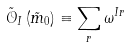<formula> <loc_0><loc_0><loc_500><loc_500>\tilde { \mathcal { O } } _ { I } \left ( \tilde { m } _ { 0 } \right ) \equiv \sum _ { r } \omega ^ { I r }</formula> 